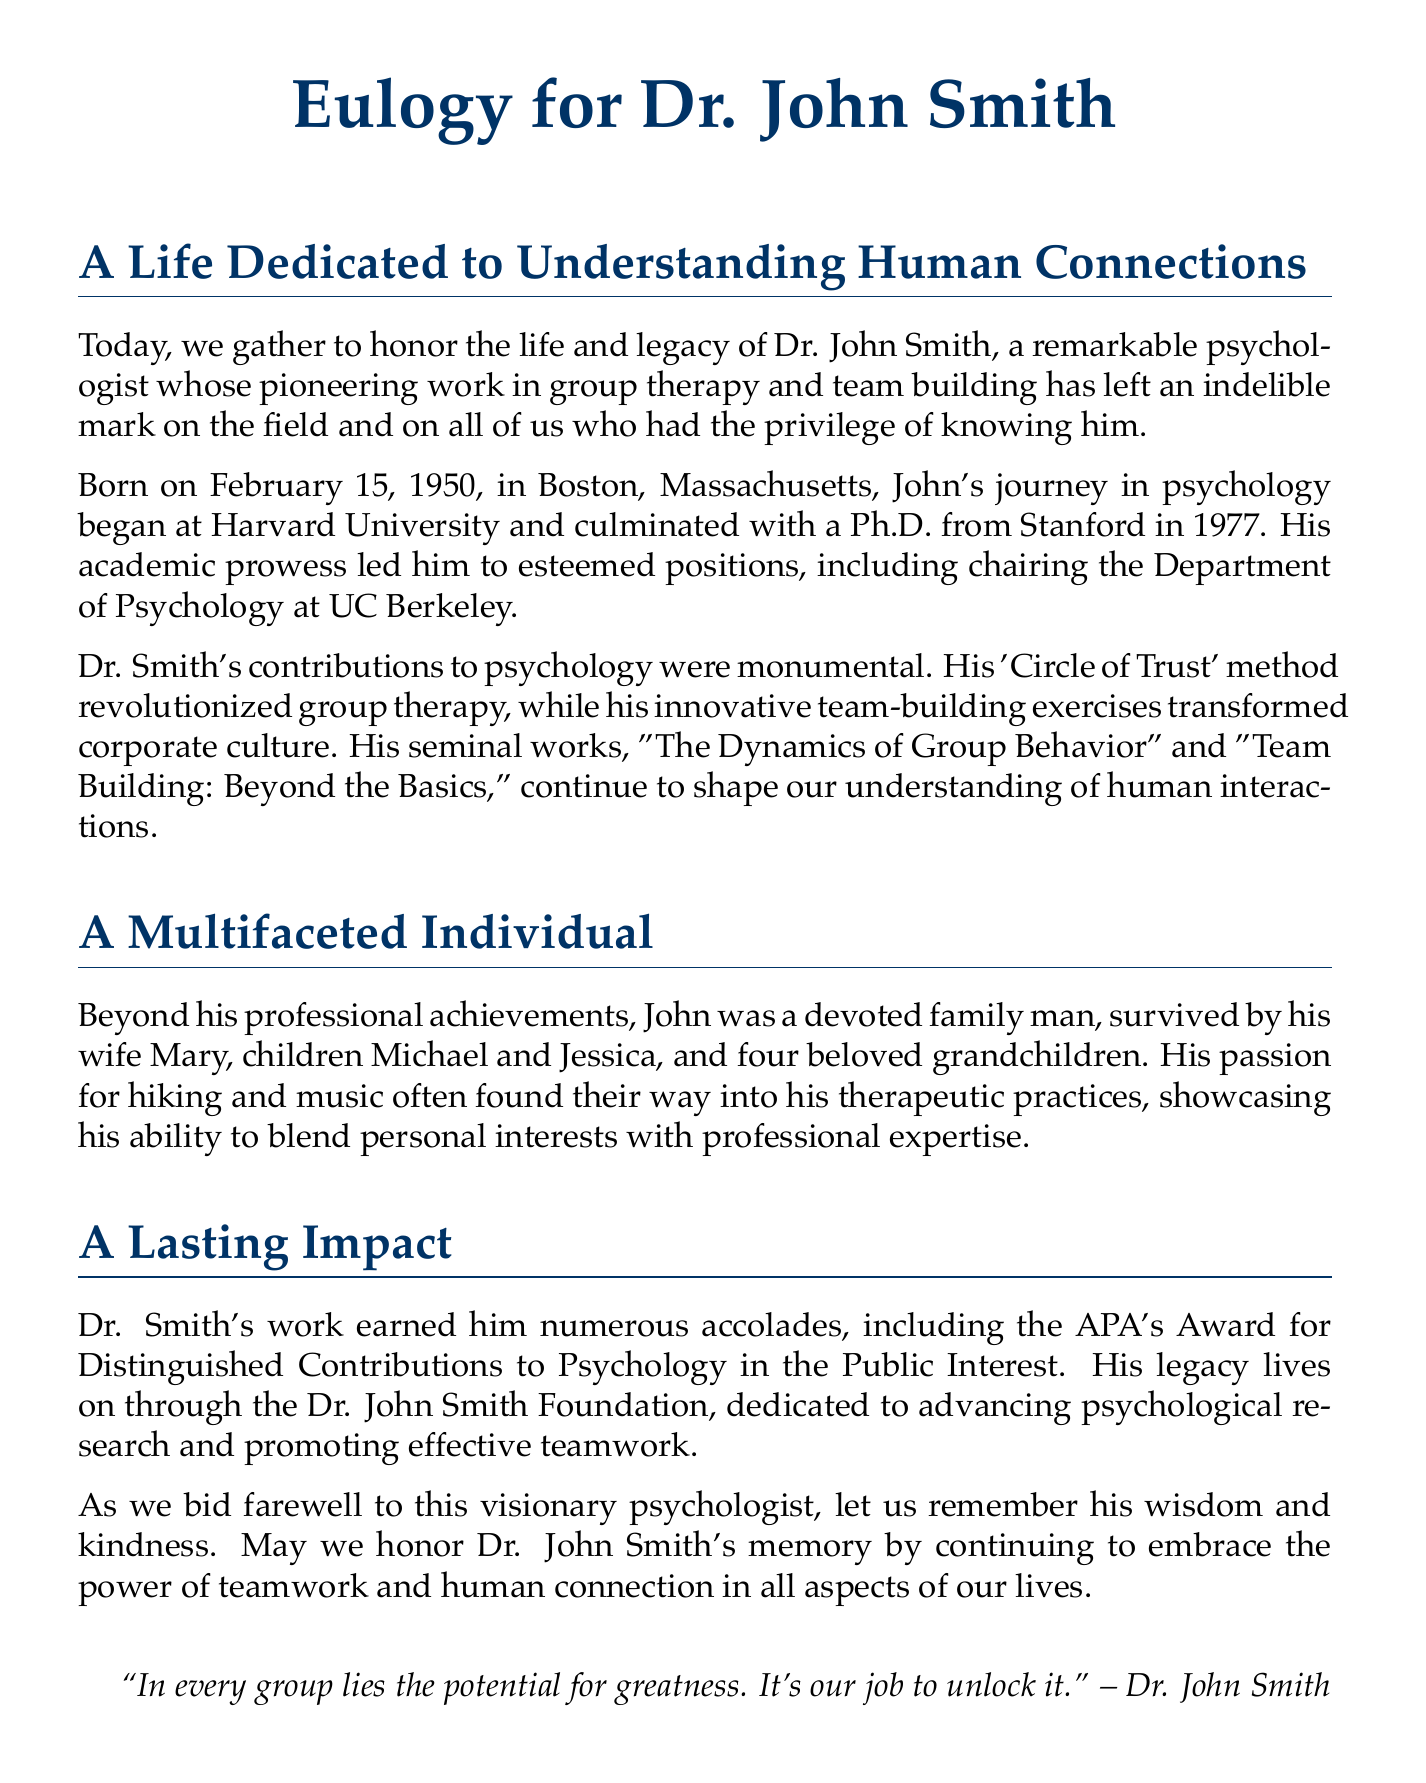What date was Dr. John Smith born? The document explicitly states that Dr. John Smith was born on February 15, 1950.
Answer: February 15, 1950 What was the title of Dr. Smith's seminal work? The document mentions two seminal works, but the question asks for a title, referring to "The Dynamics of Group Behavior."
Answer: The Dynamics of Group Behavior Which method did Dr. Smith develop? The document describes Dr. Smith's 'Circle of Trust' method as revolutionary in group therapy.
Answer: Circle of Trust How many grandchildren did Dr. Smith have? The document states that he was survived by four beloved grandchildren.
Answer: Four What award did Dr. Smith receive from the APA? The document highlights that he received the APA's Award for Distinguished Contributions to Psychology in the Public Interest.
Answer: Award for Distinguished Contributions to Psychology in the Public Interest What foundation was established in Dr. Smith's honor? The document talks about the Dr. John Smith Foundation dedicated to advancing psychological research.
Answer: Dr. John Smith Foundation What profession did Dr. Smith practice? The document clearly indicates that Dr. John Smith was a psychologist.
Answer: Psychologist How did Dr. Smith incorporate his personal interests into his work? The document notes that his passion for hiking and music often found their way into his therapeutic practices.
Answer: Hiking and music What is the main theme of Dr. Smith's legacy? The document emphasizes that his legacy involves embracing the power of teamwork and human connection.
Answer: Teamwork and human connection 